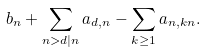<formula> <loc_0><loc_0><loc_500><loc_500>b _ { n } + \sum _ { n > d | n } a _ { d , n } - \sum _ { k \geq 1 } a _ { n , k n } .</formula> 